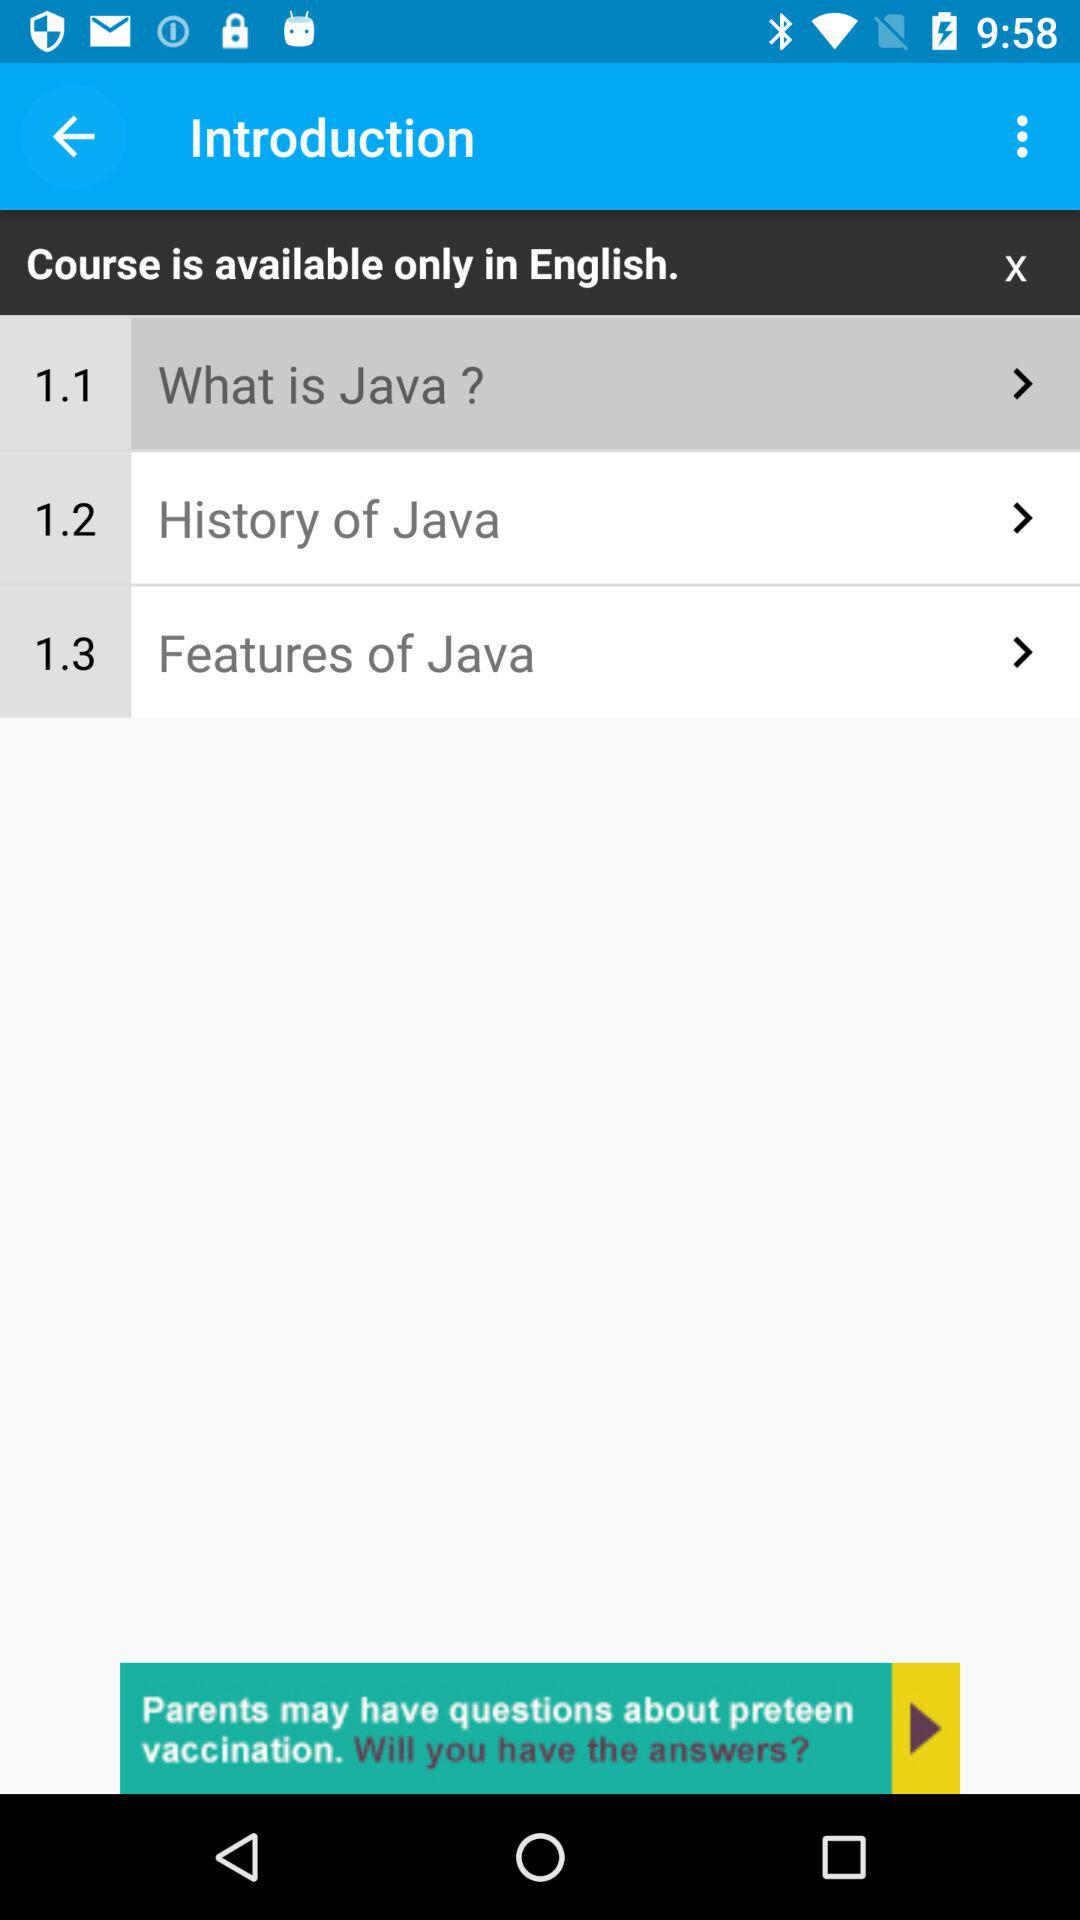What is the name of the topic 1.1? The name of the topic is "What is Java?". 